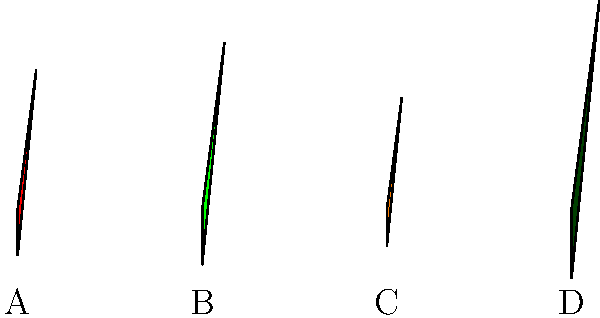In this illustration of Southern peppers, which letter corresponds to the mild, bell-shaped pepper commonly used in Cajun and Creole dishes? Let's analyze each pepper in the illustration:

1. Pepper A: This small, red pepper likely represents a cayenne or tabasco pepper, known for its heat in Southern cuisine.

2. Pepper B: This green, bell-shaped pepper is larger than the others and has the classic shape of a bell pepper. Bell peppers are mild and commonly used in many Southern dishes, particularly in Cajun and Creole cooking.

3. Pepper C: This small, orange pepper probably represents a habanero or scotch bonnet pepper, which are extremely hot and used sparingly in some Southern dishes.

4. Pepper D: This long, dark green pepper likely represents a jalapeño or serrano pepper, which have moderate heat and are used in various Southern recipes.

Given the question asks for a mild, bell-shaped pepper commonly used in Cajun and Creole dishes, the correct answer is B, which represents the bell pepper.
Answer: B 